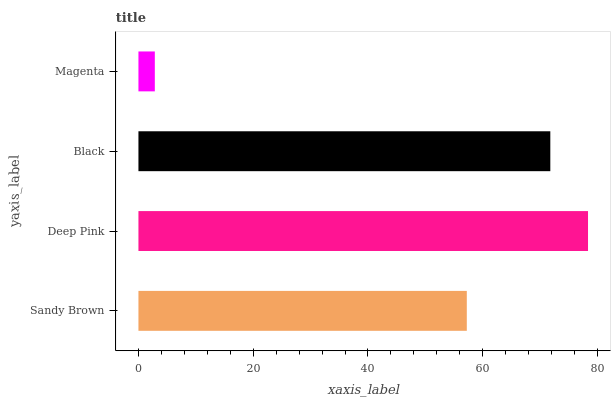Is Magenta the minimum?
Answer yes or no. Yes. Is Deep Pink the maximum?
Answer yes or no. Yes. Is Black the minimum?
Answer yes or no. No. Is Black the maximum?
Answer yes or no. No. Is Deep Pink greater than Black?
Answer yes or no. Yes. Is Black less than Deep Pink?
Answer yes or no. Yes. Is Black greater than Deep Pink?
Answer yes or no. No. Is Deep Pink less than Black?
Answer yes or no. No. Is Black the high median?
Answer yes or no. Yes. Is Sandy Brown the low median?
Answer yes or no. Yes. Is Magenta the high median?
Answer yes or no. No. Is Black the low median?
Answer yes or no. No. 